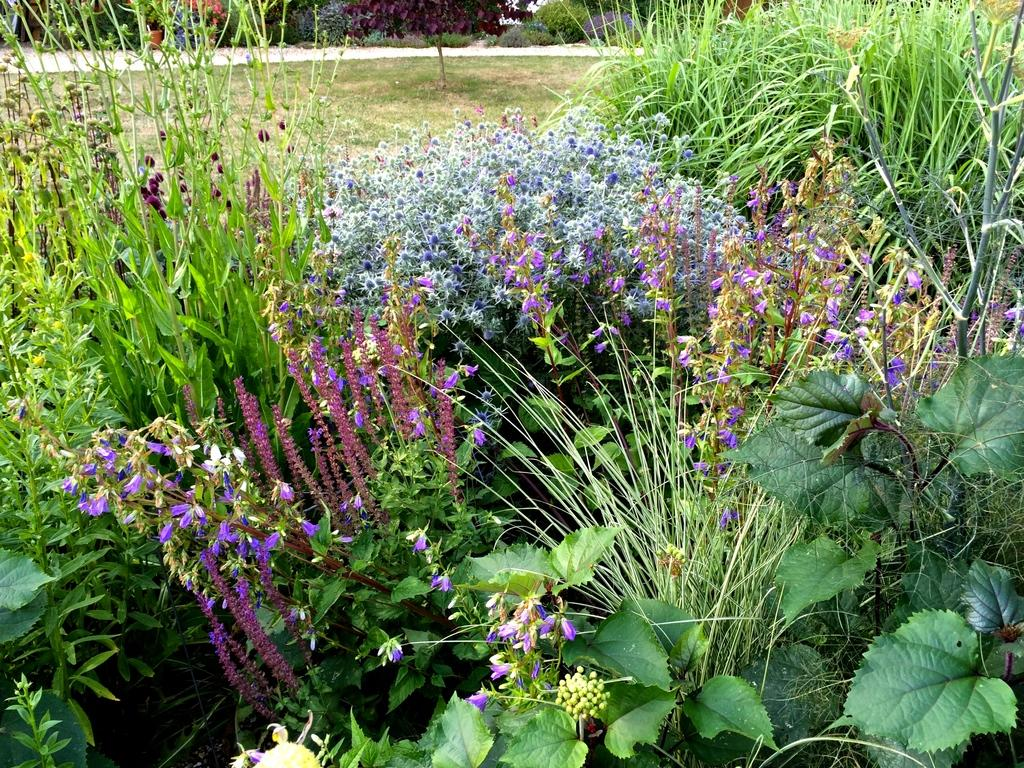What type of vegetation can be seen in the image? There are many plants in the image, including grass. What can be seen in the background of the image? There are trees in the background of the image. What type of cap is being worn by the ant in the image? There are no ants or caps present in the image. What type of industry can be seen in the background of the image? There is no industry visible in the image; it features plants, grass, and trees. 